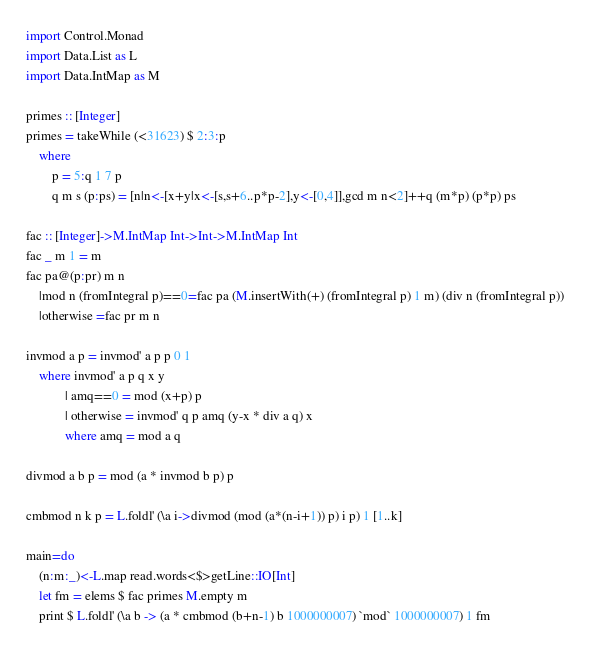Convert code to text. <code><loc_0><loc_0><loc_500><loc_500><_Haskell_>import Control.Monad
import Data.List as L
import Data.IntMap as M

primes :: [Integer]
primes = takeWhile (<31623) $ 2:3:p
    where 
        p = 5:q 1 7 p
        q m s (p:ps) = [n|n<-[x+y|x<-[s,s+6..p*p-2],y<-[0,4]],gcd m n<2]++q (m*p) (p*p) ps

fac :: [Integer]->M.IntMap Int->Int->M.IntMap Int
fac _ m 1 = m
fac pa@(p:pr) m n
    |mod n (fromIntegral p)==0=fac pa (M.insertWith(+) (fromIntegral p) 1 m) (div n (fromIntegral p))
    |otherwise =fac pr m n

invmod a p = invmod' a p p 0 1
    where invmod' a p q x y
            | amq==0 = mod (x+p) p
            | otherwise = invmod' q p amq (y-x * div a q) x
            where amq = mod a q

divmod a b p = mod (a * invmod b p) p

cmbmod n k p = L.foldl' (\a i->divmod (mod (a*(n-i+1)) p) i p) 1 [1..k]

main=do
    (n:m:_)<-L.map read.words<$>getLine::IO[Int]
    let fm = elems $ fac primes M.empty m
    print $ L.foldl' (\a b -> (a * cmbmod (b+n-1) b 1000000007) `mod` 1000000007) 1 fm</code> 